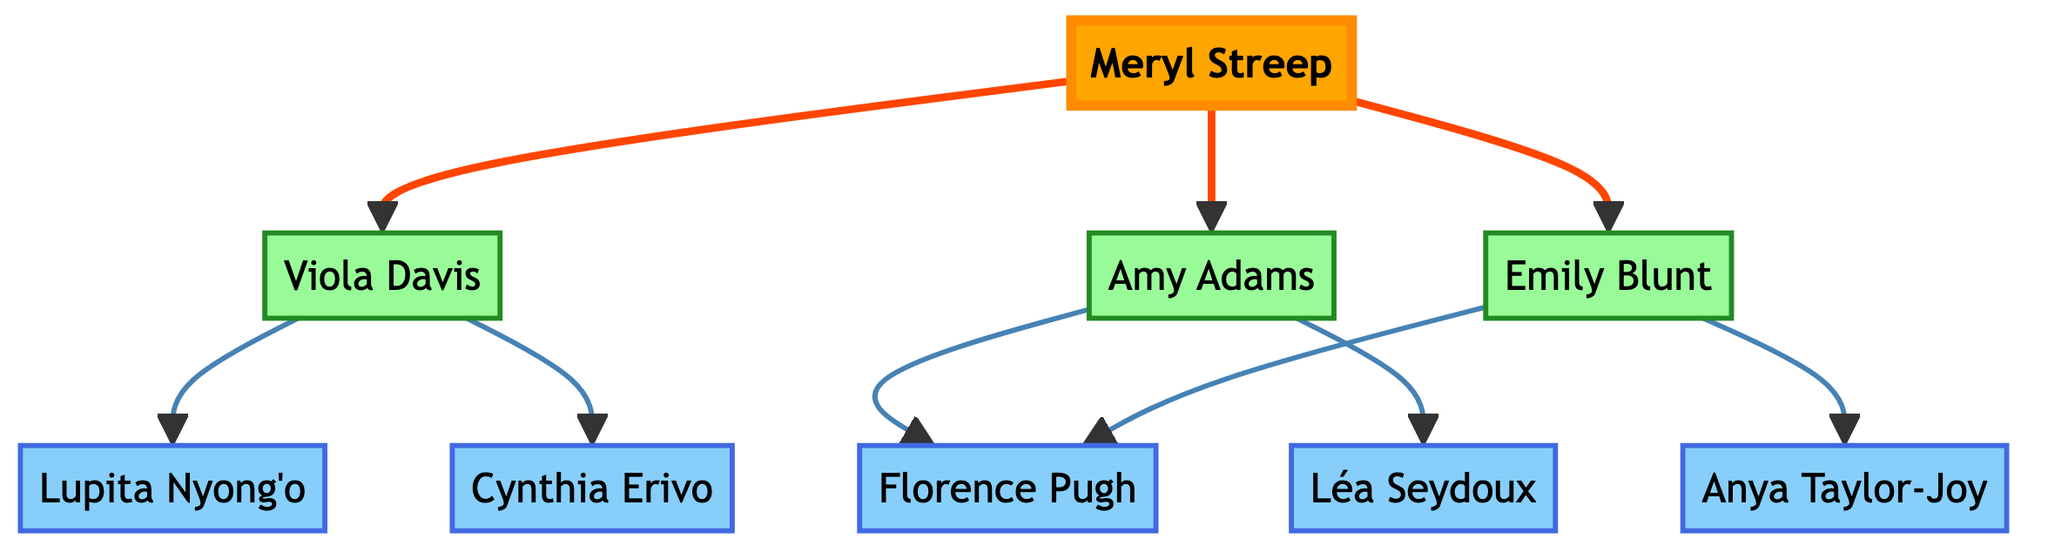What is the main actor in this mentorship tree? The main actor, as depicted at the top of the tree, is Meryl Streep. This can be identified as she has arrows pointing to her protégés.
Answer: Meryl Streep How many protégés does Meryl Streep have? Meryl Streep has three protégés represented as branching nodes directly connected to her. These are Viola Davis, Amy Adams, and Emily Blunt.
Answer: 3 Who is a protégé of both Amy Adams and Emily Blunt? The actor Florence Pugh appears as a protégé of both Amy Adams and Emily Blunt, as both have arrows pointing to her. Therefore, she shares a connection with both actors.
Answer: Florence Pugh Which actor has the most protégés in this tree? Meryl Streep is the only main actor and has the most protégés, totaling three distinct actors. Each of her protégés—Viola Davis, Amy Adams, and Emily Blunt—has their own connections, but Meryl remains the primary figure with the count.
Answer: Meryl Streep How many sub-protégés does Viola Davis have? Viola Davis has two sub-protégés, Lupita Nyong'o and Cynthia Erivo, both directly inherited from her in the mentorship hierarchy. This is evident from the branches extending from Viola Davis's node.
Answer: 2 What is the relationship between Emily Blunt and Anya Taylor-Joy? Anya Taylor-Joy is a protégé of Emily Blunt. This is shown by the arrow connecting the two, indicating that Emily Blunt mentored her.
Answer: Protégé Which actor is directly mentored by Viola Davis? Viola Davis directly mentors Lupita Nyong'o and Cynthia Erivo, as indicated by the two branches stemming directly from her node, each leading to one of those actors.
Answer: Lupita Nyong'o and Cynthia Erivo How many actors are there in total in the mentorship tree? The mentorship tree includes one main actor, three protégés, and five sub-protégés. Adding these together, the total number of actors amounts to nine in the tree.
Answer: 9 What is the depth of the mentorship tree from Meryl Streep to her sub-protégés? The depth of the tree from Meryl Streep, who is the root, to her sub-protégés (Lupita Nyong'o, Cynthia Erivo, Florence Pugh, Léa Seydoux, and Anya Taylor-Joy) is two levels deep. Meryl Streep is the first level, and her direct protégés form the second level.
Answer: 2 